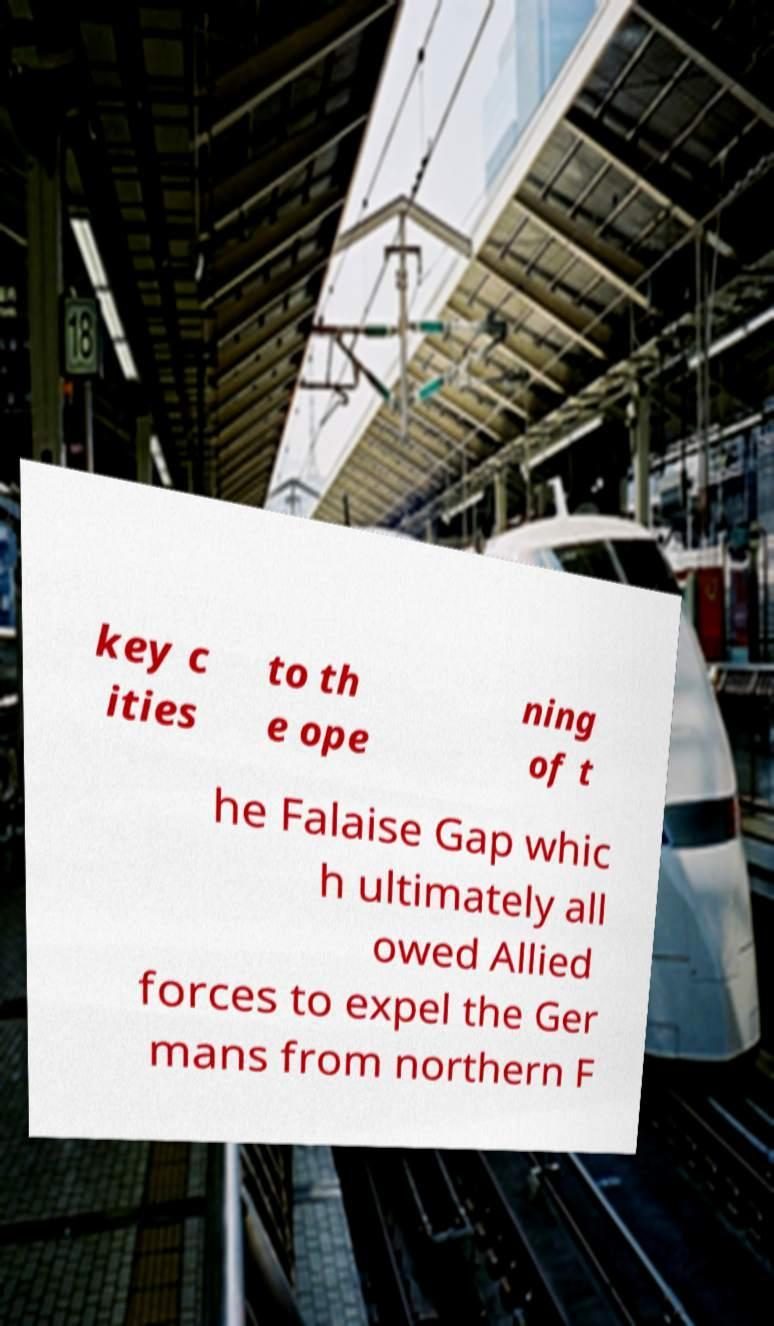For documentation purposes, I need the text within this image transcribed. Could you provide that? key c ities to th e ope ning of t he Falaise Gap whic h ultimately all owed Allied forces to expel the Ger mans from northern F 